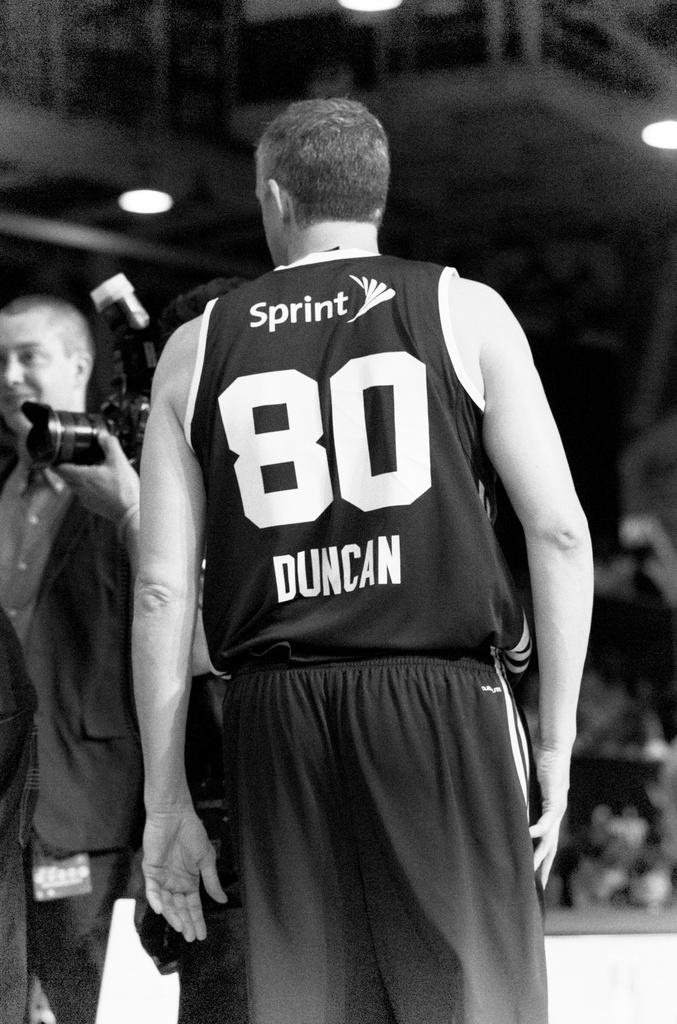What number is on the jersey?
Your response must be concise. 80. 